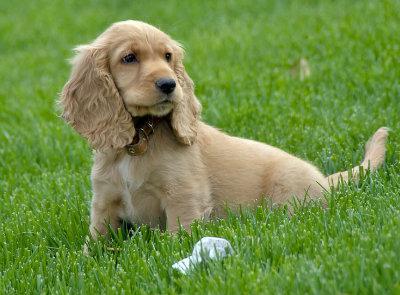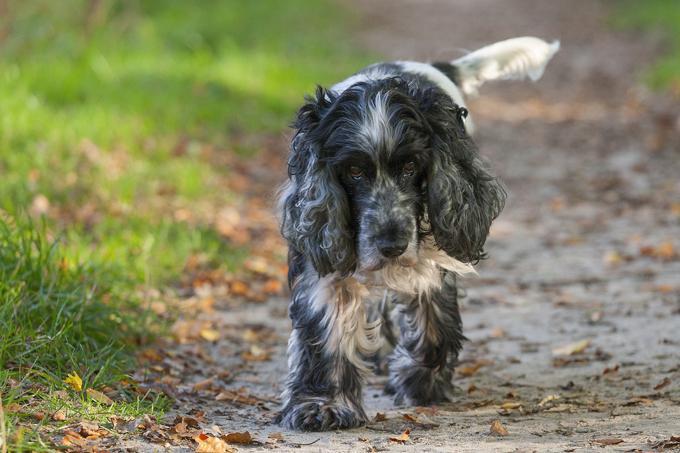The first image is the image on the left, the second image is the image on the right. Evaluate the accuracy of this statement regarding the images: "The brown dogs in the image on the right are sitting outside.". Is it true? Answer yes or no. No. The first image is the image on the left, the second image is the image on the right. Considering the images on both sides, is "The dog in the image on the right is on a dirt pathway in the grass." valid? Answer yes or no. Yes. The first image is the image on the left, the second image is the image on the right. Evaluate the accuracy of this statement regarding the images: "The dog in the right image is walking on the grass in profile.". Is it true? Answer yes or no. No. The first image is the image on the left, the second image is the image on the right. For the images displayed, is the sentence "Right image shows at least one golden-haired dog sitting upright." factually correct? Answer yes or no. No. 